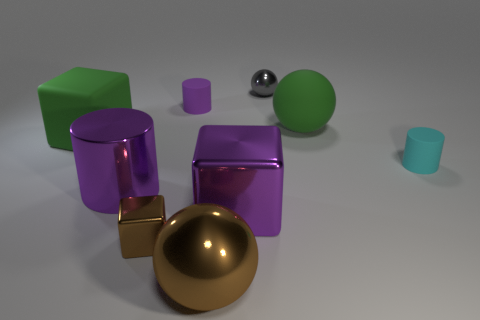What kind of ambiance or mood does the lighting and arrangement of the objects create in this image? The ambient lighting and neat arrangement of the objects produce a calm and orderly atmosphere. The soft shadows and gentle reflections contribute to a serene vibe, almost as if the scene is a study in form and material. 